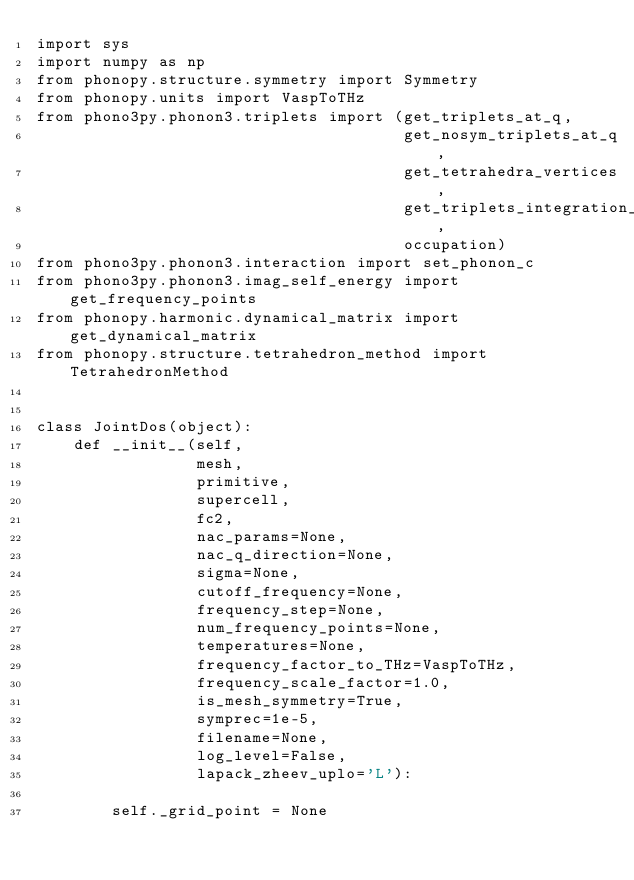<code> <loc_0><loc_0><loc_500><loc_500><_Python_>import sys
import numpy as np
from phonopy.structure.symmetry import Symmetry
from phonopy.units import VaspToTHz
from phono3py.phonon3.triplets import (get_triplets_at_q,
                                       get_nosym_triplets_at_q,
                                       get_tetrahedra_vertices,
                                       get_triplets_integration_weights,
                                       occupation)
from phono3py.phonon3.interaction import set_phonon_c
from phono3py.phonon3.imag_self_energy import get_frequency_points
from phonopy.harmonic.dynamical_matrix import get_dynamical_matrix
from phonopy.structure.tetrahedron_method import TetrahedronMethod


class JointDos(object):
    def __init__(self,
                 mesh,
                 primitive,
                 supercell,
                 fc2,
                 nac_params=None,
                 nac_q_direction=None,
                 sigma=None,
                 cutoff_frequency=None,
                 frequency_step=None,
                 num_frequency_points=None,
                 temperatures=None,
                 frequency_factor_to_THz=VaspToTHz,
                 frequency_scale_factor=1.0,
                 is_mesh_symmetry=True,
                 symprec=1e-5,
                 filename=None,
                 log_level=False,
                 lapack_zheev_uplo='L'):

        self._grid_point = None</code> 